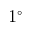Convert formula to latex. <formula><loc_0><loc_0><loc_500><loc_500>1 ^ { \circ }</formula> 